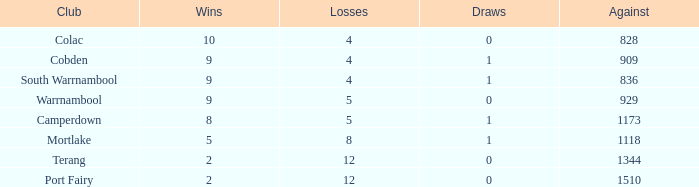What is the total number of Against values for clubs with more than 2 wins, 5 losses, and 0 draws? 0.0. 